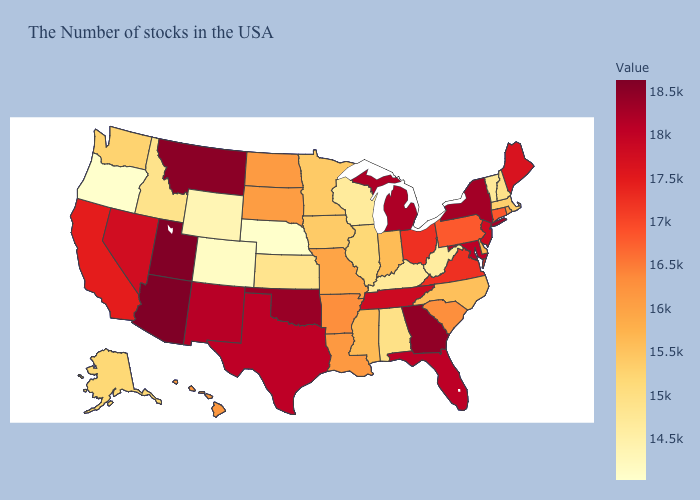Does Alaska have a higher value than New York?
Give a very brief answer. No. Which states have the lowest value in the South?
Concise answer only. West Virginia. Does the map have missing data?
Quick response, please. No. 